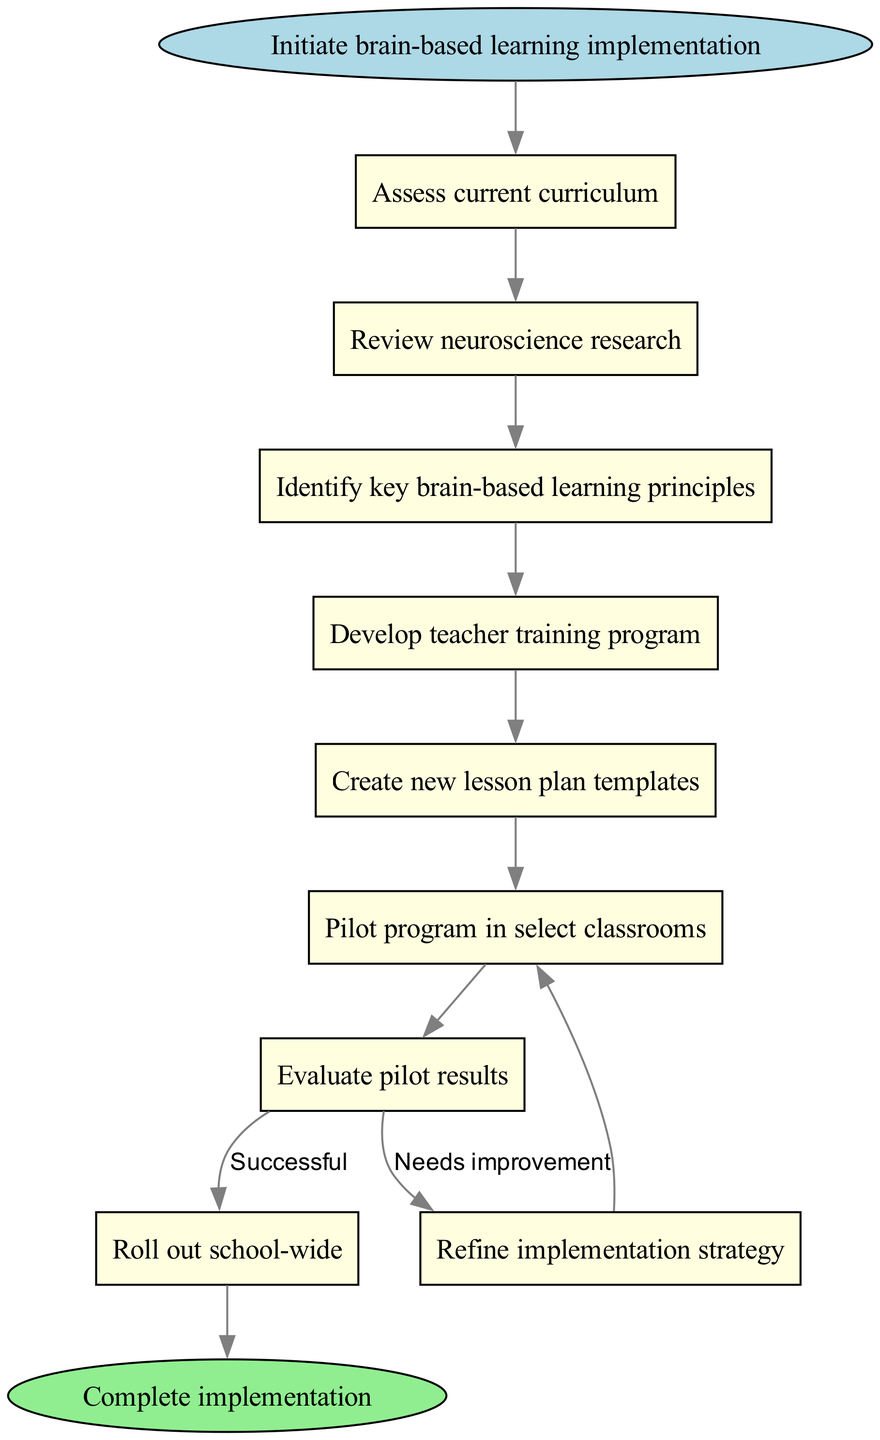What is the first step in the flowchart? The first step, as indicated by the starting node, is "Initiate brain-based learning implementation."
Answer: Initiate brain-based learning implementation How many main nodes are there in the flowchart? The flowchart has 9 main nodes, including the start and end nodes. Counting all nodes defined in the data, there are a total of 9.
Answer: 9 What happens after "Pilot program in select classrooms"? After "Pilot program in select classrooms," the next step is "Evaluate pilot results." This is a direct transition from one step to the next as per the flowchart's edges.
Answer: Evaluate pilot results What is the node that follows "Review neuroscience research"? The node that follows "Review neuroscience research" is "Identify key brain-based learning principles," connected directly by an edge in the diagram.
Answer: Identify key brain-based learning principles If the pilot results are evaluated as "Successful," what is the next step? If the pilot results are deemed "Successful," the next step is to "Roll out school-wide," which is the concluding action based on this evaluation path in the flowchart.
Answer: Roll out school-wide After "Evaluate pilot results," what happens if there are "Needs improvement"? If "Evaluate pilot results" indicates "Needs improvement," the flowchart leads back to "Pilot program in select classrooms." This loop allows for adjustments before proceeding further.
Answer: Pilot program in select classrooms What are the two outcomes from the "Evaluate pilot results" node? The two outcomes from the "Evaluate pilot results" node are "Needs improvement" and "Successful." Both outcomes branch off from this evaluation.
Answer: Needs improvement, Successful What is the last action in the process? The last action in the process, as depicted in the flowchart, is "Complete implementation," which is reached after the successful rollout of the new strategies.
Answer: Complete implementation 